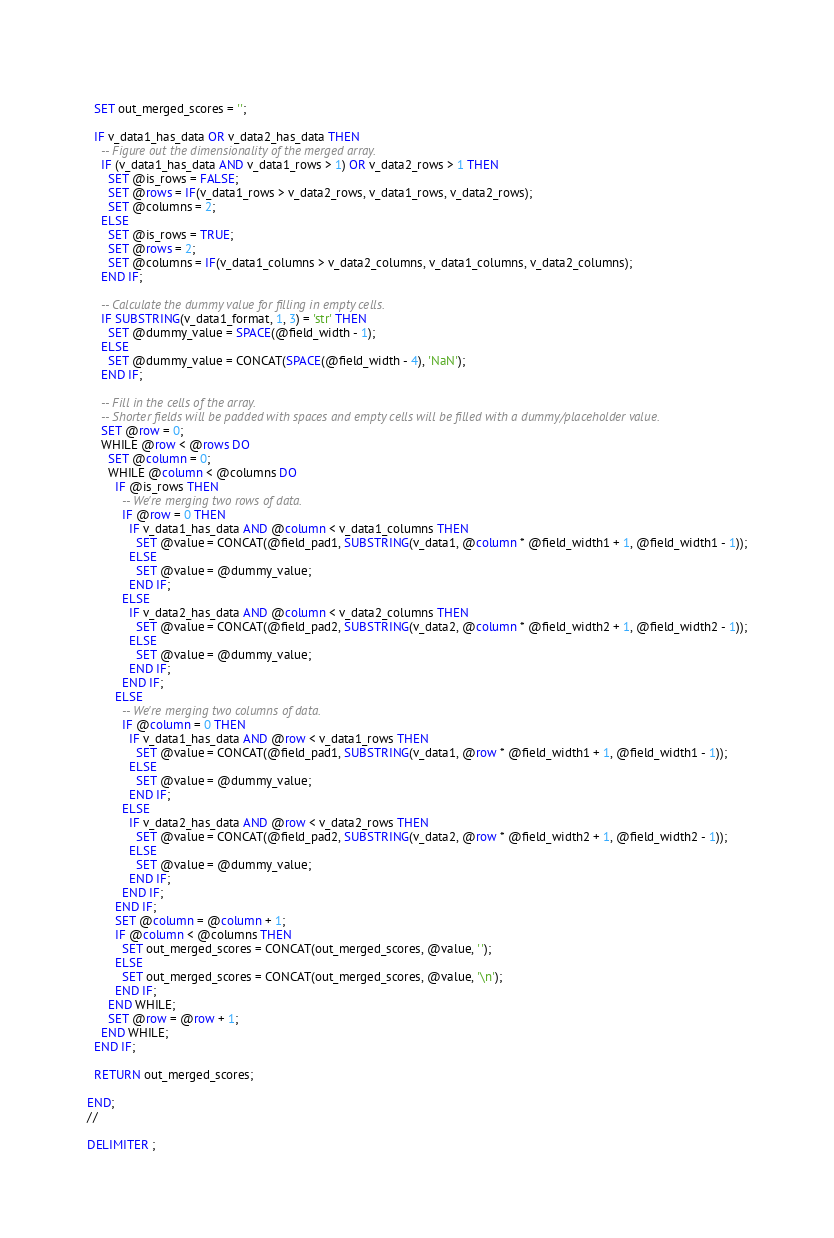<code> <loc_0><loc_0><loc_500><loc_500><_SQL_>  
  SET out_merged_scores = '';
  
  IF v_data1_has_data OR v_data2_has_data THEN
    -- Figure out the dimensionality of the merged array.
    IF (v_data1_has_data AND v_data1_rows > 1) OR v_data2_rows > 1 THEN
      SET @is_rows = FALSE;
      SET @rows = IF(v_data1_rows > v_data2_rows, v_data1_rows, v_data2_rows);
      SET @columns = 2;
    ELSE
      SET @is_rows = TRUE;
      SET @rows = 2;
      SET @columns = IF(v_data1_columns > v_data2_columns, v_data1_columns, v_data2_columns);
    END IF;
    
    -- Calculate the dummy value for filling in empty cells.
    IF SUBSTRING(v_data1_format, 1, 3) = 'str' THEN
      SET @dummy_value = SPACE(@field_width - 1);
    ELSE
      SET @dummy_value = CONCAT(SPACE(@field_width - 4), 'NaN');
    END IF;
    
    -- Fill in the cells of the array.
    -- Shorter fields will be padded with spaces and empty cells will be filled with a dummy/placeholder value.
    SET @row = 0;
    WHILE @row < @rows DO
      SET @column = 0;
      WHILE @column < @columns DO
        IF @is_rows THEN
          -- We're merging two rows of data.
          IF @row = 0 THEN
            IF v_data1_has_data AND @column < v_data1_columns THEN
              SET @value = CONCAT(@field_pad1, SUBSTRING(v_data1, @column * @field_width1 + 1, @field_width1 - 1));
            ELSE
              SET @value = @dummy_value;
            END IF;
          ELSE
            IF v_data2_has_data AND @column < v_data2_columns THEN
              SET @value = CONCAT(@field_pad2, SUBSTRING(v_data2, @column * @field_width2 + 1, @field_width2 - 1));
            ELSE
              SET @value = @dummy_value;
            END IF;
          END IF;
        ELSE
          -- We're merging two columns of data.
          IF @column = 0 THEN
            IF v_data1_has_data AND @row < v_data1_rows THEN
              SET @value = CONCAT(@field_pad1, SUBSTRING(v_data1, @row * @field_width1 + 1, @field_width1 - 1));
            ELSE
              SET @value = @dummy_value;
            END IF;
          ELSE
            IF v_data2_has_data AND @row < v_data2_rows THEN
              SET @value = CONCAT(@field_pad2, SUBSTRING(v_data2, @row * @field_width2 + 1, @field_width2 - 1));
            ELSE
              SET @value = @dummy_value;
            END IF;
          END IF;
        END IF;
        SET @column = @column + 1;
        IF @column < @columns THEN
          SET out_merged_scores = CONCAT(out_merged_scores, @value, ' ');
        ELSE
          SET out_merged_scores = CONCAT(out_merged_scores, @value, '\n');
        END IF;
      END WHILE;
      SET @row = @row + 1;
    END WHILE;
  END IF;
  
  RETURN out_merged_scores;

END;
//

DELIMITER ;
</code> 